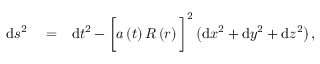Convert formula to latex. <formula><loc_0><loc_0><loc_500><loc_500>\begin{array} { r l r } { d s ^ { 2 } } & = } & { d t ^ { 2 } - \left [ a \left ( t \right ) R \left ( r \right ) \right ] ^ { 2 } \left ( d x ^ { 2 } + d y ^ { 2 } + d z ^ { 2 } \right ) , } \end{array}</formula> 